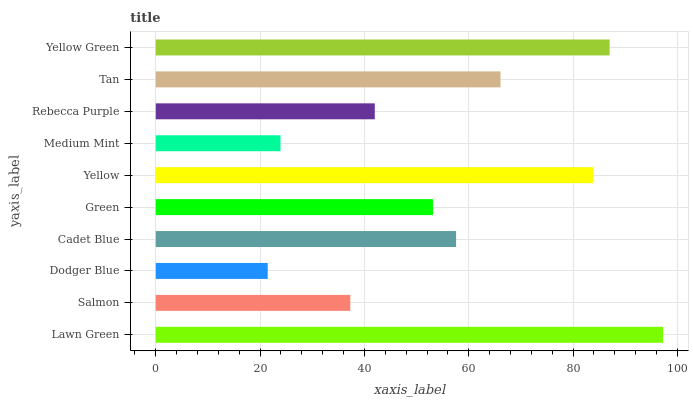Is Dodger Blue the minimum?
Answer yes or no. Yes. Is Lawn Green the maximum?
Answer yes or no. Yes. Is Salmon the minimum?
Answer yes or no. No. Is Salmon the maximum?
Answer yes or no. No. Is Lawn Green greater than Salmon?
Answer yes or no. Yes. Is Salmon less than Lawn Green?
Answer yes or no. Yes. Is Salmon greater than Lawn Green?
Answer yes or no. No. Is Lawn Green less than Salmon?
Answer yes or no. No. Is Cadet Blue the high median?
Answer yes or no. Yes. Is Green the low median?
Answer yes or no. Yes. Is Yellow the high median?
Answer yes or no. No. Is Lawn Green the low median?
Answer yes or no. No. 